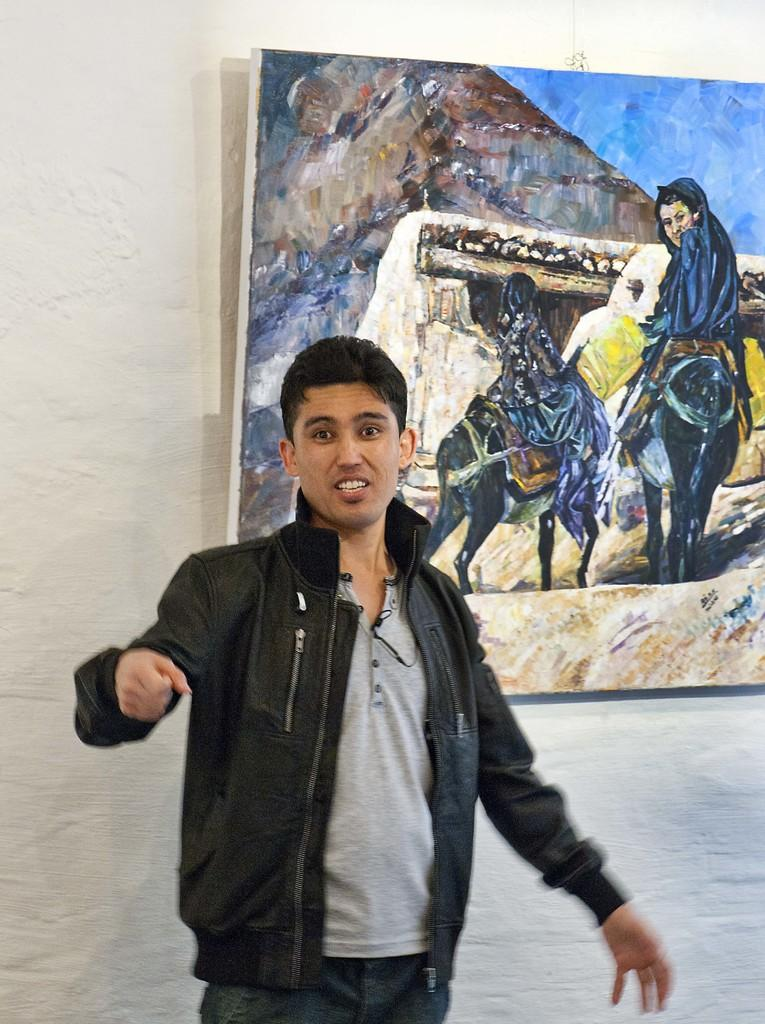Who is present in the image? There is a man in the image. What can be seen in the background of the image? There is a wall in the background of the image. What is on the wall in the image? There is a painting on the wall. What type of reward is the man holding in the image? There is no reward present in the image; the man is not holding anything. 